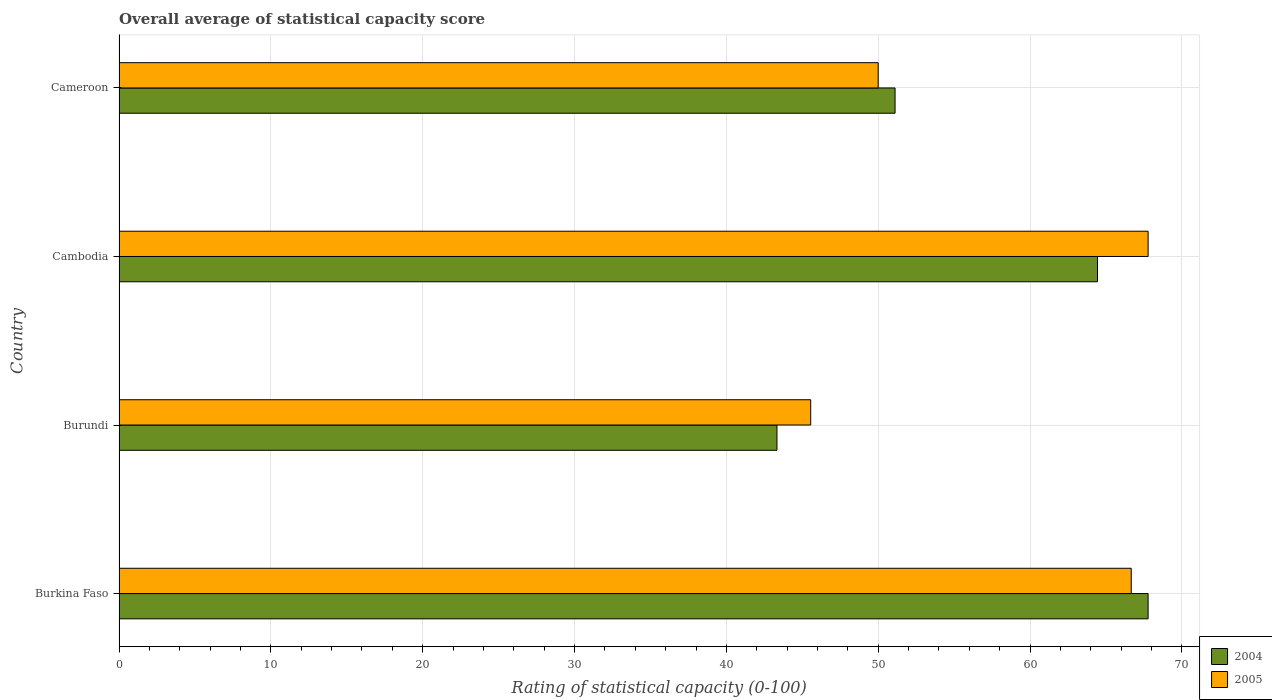How many different coloured bars are there?
Give a very brief answer. 2. Are the number of bars on each tick of the Y-axis equal?
Your answer should be very brief. Yes. How many bars are there on the 2nd tick from the top?
Offer a very short reply. 2. How many bars are there on the 4th tick from the bottom?
Ensure brevity in your answer.  2. What is the label of the 1st group of bars from the top?
Offer a very short reply. Cameroon. What is the rating of statistical capacity in 2005 in Cameroon?
Keep it short and to the point. 50. Across all countries, what is the maximum rating of statistical capacity in 2005?
Offer a terse response. 67.78. Across all countries, what is the minimum rating of statistical capacity in 2004?
Offer a terse response. 43.33. In which country was the rating of statistical capacity in 2004 maximum?
Provide a short and direct response. Burkina Faso. In which country was the rating of statistical capacity in 2005 minimum?
Offer a very short reply. Burundi. What is the total rating of statistical capacity in 2004 in the graph?
Provide a short and direct response. 226.67. What is the difference between the rating of statistical capacity in 2005 in Burkina Faso and that in Burundi?
Your answer should be compact. 21.11. What is the difference between the rating of statistical capacity in 2004 in Cambodia and the rating of statistical capacity in 2005 in Burkina Faso?
Your answer should be compact. -2.22. What is the average rating of statistical capacity in 2004 per country?
Provide a succinct answer. 56.67. What is the difference between the rating of statistical capacity in 2004 and rating of statistical capacity in 2005 in Cambodia?
Offer a terse response. -3.33. In how many countries, is the rating of statistical capacity in 2005 greater than 44 ?
Your answer should be very brief. 4. What is the ratio of the rating of statistical capacity in 2005 in Burundi to that in Cambodia?
Keep it short and to the point. 0.67. Is the rating of statistical capacity in 2004 in Burkina Faso less than that in Cameroon?
Offer a very short reply. No. What is the difference between the highest and the second highest rating of statistical capacity in 2004?
Your answer should be compact. 3.33. What is the difference between the highest and the lowest rating of statistical capacity in 2005?
Offer a terse response. 22.22. In how many countries, is the rating of statistical capacity in 2005 greater than the average rating of statistical capacity in 2005 taken over all countries?
Your response must be concise. 2. Is the sum of the rating of statistical capacity in 2005 in Burkina Faso and Cameroon greater than the maximum rating of statistical capacity in 2004 across all countries?
Ensure brevity in your answer.  Yes. What does the 2nd bar from the bottom in Burundi represents?
Offer a terse response. 2005. How many bars are there?
Keep it short and to the point. 8. How many countries are there in the graph?
Keep it short and to the point. 4. What is the difference between two consecutive major ticks on the X-axis?
Keep it short and to the point. 10. Does the graph contain any zero values?
Your answer should be compact. No. Does the graph contain grids?
Your response must be concise. Yes. What is the title of the graph?
Offer a very short reply. Overall average of statistical capacity score. Does "1981" appear as one of the legend labels in the graph?
Your response must be concise. No. What is the label or title of the X-axis?
Keep it short and to the point. Rating of statistical capacity (0-100). What is the Rating of statistical capacity (0-100) in 2004 in Burkina Faso?
Offer a terse response. 67.78. What is the Rating of statistical capacity (0-100) in 2005 in Burkina Faso?
Your answer should be very brief. 66.67. What is the Rating of statistical capacity (0-100) of 2004 in Burundi?
Your response must be concise. 43.33. What is the Rating of statistical capacity (0-100) in 2005 in Burundi?
Offer a terse response. 45.56. What is the Rating of statistical capacity (0-100) in 2004 in Cambodia?
Your answer should be very brief. 64.44. What is the Rating of statistical capacity (0-100) of 2005 in Cambodia?
Ensure brevity in your answer.  67.78. What is the Rating of statistical capacity (0-100) of 2004 in Cameroon?
Your answer should be very brief. 51.11. Across all countries, what is the maximum Rating of statistical capacity (0-100) of 2004?
Ensure brevity in your answer.  67.78. Across all countries, what is the maximum Rating of statistical capacity (0-100) in 2005?
Your response must be concise. 67.78. Across all countries, what is the minimum Rating of statistical capacity (0-100) of 2004?
Offer a terse response. 43.33. Across all countries, what is the minimum Rating of statistical capacity (0-100) of 2005?
Your answer should be very brief. 45.56. What is the total Rating of statistical capacity (0-100) of 2004 in the graph?
Give a very brief answer. 226.67. What is the total Rating of statistical capacity (0-100) of 2005 in the graph?
Provide a succinct answer. 230. What is the difference between the Rating of statistical capacity (0-100) in 2004 in Burkina Faso and that in Burundi?
Your answer should be very brief. 24.44. What is the difference between the Rating of statistical capacity (0-100) in 2005 in Burkina Faso and that in Burundi?
Offer a terse response. 21.11. What is the difference between the Rating of statistical capacity (0-100) in 2004 in Burkina Faso and that in Cambodia?
Offer a very short reply. 3.33. What is the difference between the Rating of statistical capacity (0-100) in 2005 in Burkina Faso and that in Cambodia?
Provide a short and direct response. -1.11. What is the difference between the Rating of statistical capacity (0-100) of 2004 in Burkina Faso and that in Cameroon?
Your answer should be very brief. 16.67. What is the difference between the Rating of statistical capacity (0-100) of 2005 in Burkina Faso and that in Cameroon?
Your answer should be compact. 16.67. What is the difference between the Rating of statistical capacity (0-100) in 2004 in Burundi and that in Cambodia?
Your answer should be very brief. -21.11. What is the difference between the Rating of statistical capacity (0-100) in 2005 in Burundi and that in Cambodia?
Offer a very short reply. -22.22. What is the difference between the Rating of statistical capacity (0-100) in 2004 in Burundi and that in Cameroon?
Keep it short and to the point. -7.78. What is the difference between the Rating of statistical capacity (0-100) of 2005 in Burundi and that in Cameroon?
Offer a very short reply. -4.44. What is the difference between the Rating of statistical capacity (0-100) in 2004 in Cambodia and that in Cameroon?
Give a very brief answer. 13.33. What is the difference between the Rating of statistical capacity (0-100) in 2005 in Cambodia and that in Cameroon?
Make the answer very short. 17.78. What is the difference between the Rating of statistical capacity (0-100) of 2004 in Burkina Faso and the Rating of statistical capacity (0-100) of 2005 in Burundi?
Your response must be concise. 22.22. What is the difference between the Rating of statistical capacity (0-100) in 2004 in Burkina Faso and the Rating of statistical capacity (0-100) in 2005 in Cambodia?
Offer a terse response. 0. What is the difference between the Rating of statistical capacity (0-100) in 2004 in Burkina Faso and the Rating of statistical capacity (0-100) in 2005 in Cameroon?
Ensure brevity in your answer.  17.78. What is the difference between the Rating of statistical capacity (0-100) in 2004 in Burundi and the Rating of statistical capacity (0-100) in 2005 in Cambodia?
Your answer should be very brief. -24.44. What is the difference between the Rating of statistical capacity (0-100) of 2004 in Burundi and the Rating of statistical capacity (0-100) of 2005 in Cameroon?
Your answer should be compact. -6.67. What is the difference between the Rating of statistical capacity (0-100) in 2004 in Cambodia and the Rating of statistical capacity (0-100) in 2005 in Cameroon?
Keep it short and to the point. 14.44. What is the average Rating of statistical capacity (0-100) in 2004 per country?
Give a very brief answer. 56.67. What is the average Rating of statistical capacity (0-100) in 2005 per country?
Your response must be concise. 57.5. What is the difference between the Rating of statistical capacity (0-100) in 2004 and Rating of statistical capacity (0-100) in 2005 in Burundi?
Give a very brief answer. -2.22. What is the difference between the Rating of statistical capacity (0-100) of 2004 and Rating of statistical capacity (0-100) of 2005 in Cameroon?
Provide a short and direct response. 1.11. What is the ratio of the Rating of statistical capacity (0-100) in 2004 in Burkina Faso to that in Burundi?
Your answer should be compact. 1.56. What is the ratio of the Rating of statistical capacity (0-100) of 2005 in Burkina Faso to that in Burundi?
Your response must be concise. 1.46. What is the ratio of the Rating of statistical capacity (0-100) in 2004 in Burkina Faso to that in Cambodia?
Make the answer very short. 1.05. What is the ratio of the Rating of statistical capacity (0-100) of 2005 in Burkina Faso to that in Cambodia?
Give a very brief answer. 0.98. What is the ratio of the Rating of statistical capacity (0-100) of 2004 in Burkina Faso to that in Cameroon?
Your answer should be compact. 1.33. What is the ratio of the Rating of statistical capacity (0-100) of 2005 in Burkina Faso to that in Cameroon?
Your answer should be very brief. 1.33. What is the ratio of the Rating of statistical capacity (0-100) of 2004 in Burundi to that in Cambodia?
Make the answer very short. 0.67. What is the ratio of the Rating of statistical capacity (0-100) in 2005 in Burundi to that in Cambodia?
Your answer should be compact. 0.67. What is the ratio of the Rating of statistical capacity (0-100) of 2004 in Burundi to that in Cameroon?
Make the answer very short. 0.85. What is the ratio of the Rating of statistical capacity (0-100) of 2005 in Burundi to that in Cameroon?
Give a very brief answer. 0.91. What is the ratio of the Rating of statistical capacity (0-100) of 2004 in Cambodia to that in Cameroon?
Provide a short and direct response. 1.26. What is the ratio of the Rating of statistical capacity (0-100) in 2005 in Cambodia to that in Cameroon?
Ensure brevity in your answer.  1.36. What is the difference between the highest and the second highest Rating of statistical capacity (0-100) in 2004?
Offer a terse response. 3.33. What is the difference between the highest and the lowest Rating of statistical capacity (0-100) in 2004?
Ensure brevity in your answer.  24.44. What is the difference between the highest and the lowest Rating of statistical capacity (0-100) of 2005?
Your answer should be compact. 22.22. 